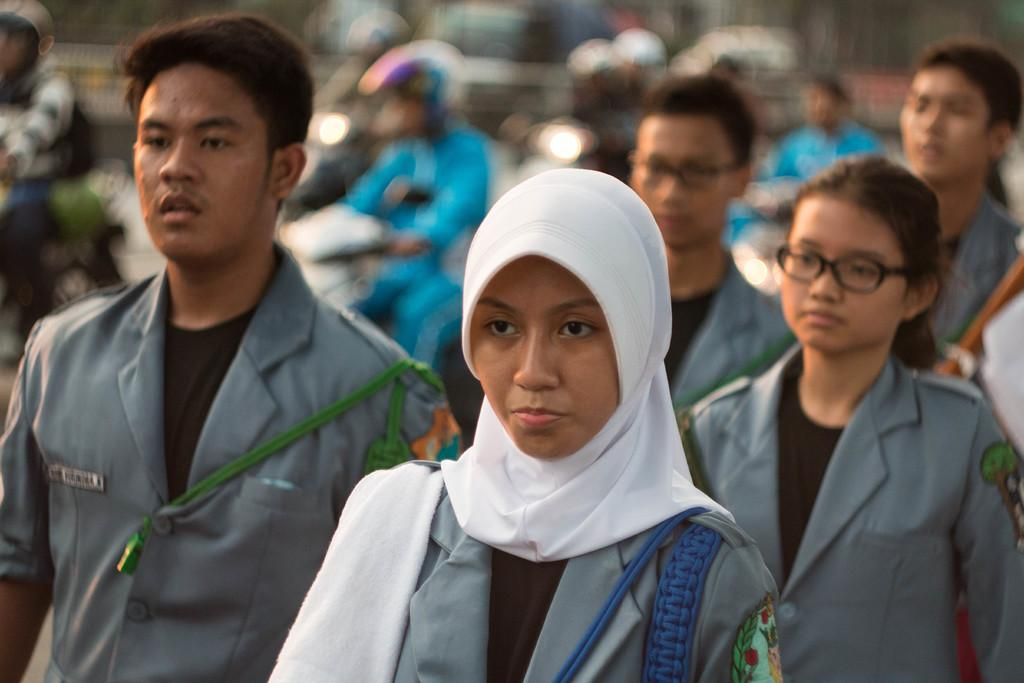What are the people in the image doing? There are people standing and riding bikes in the image. Can you describe the people who are riding bikes? The people riding bikes are blurred, indicating they are in motion. How many stamps are on the scarf worn by one of the people in the image? There is no scarf or stamp present in the image. What is the amount of money being exchanged between the people in the image? There is no indication of any exchange of money in the image. 